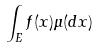Convert formula to latex. <formula><loc_0><loc_0><loc_500><loc_500>\int _ { E } f ( x ) \mu ( d x )</formula> 